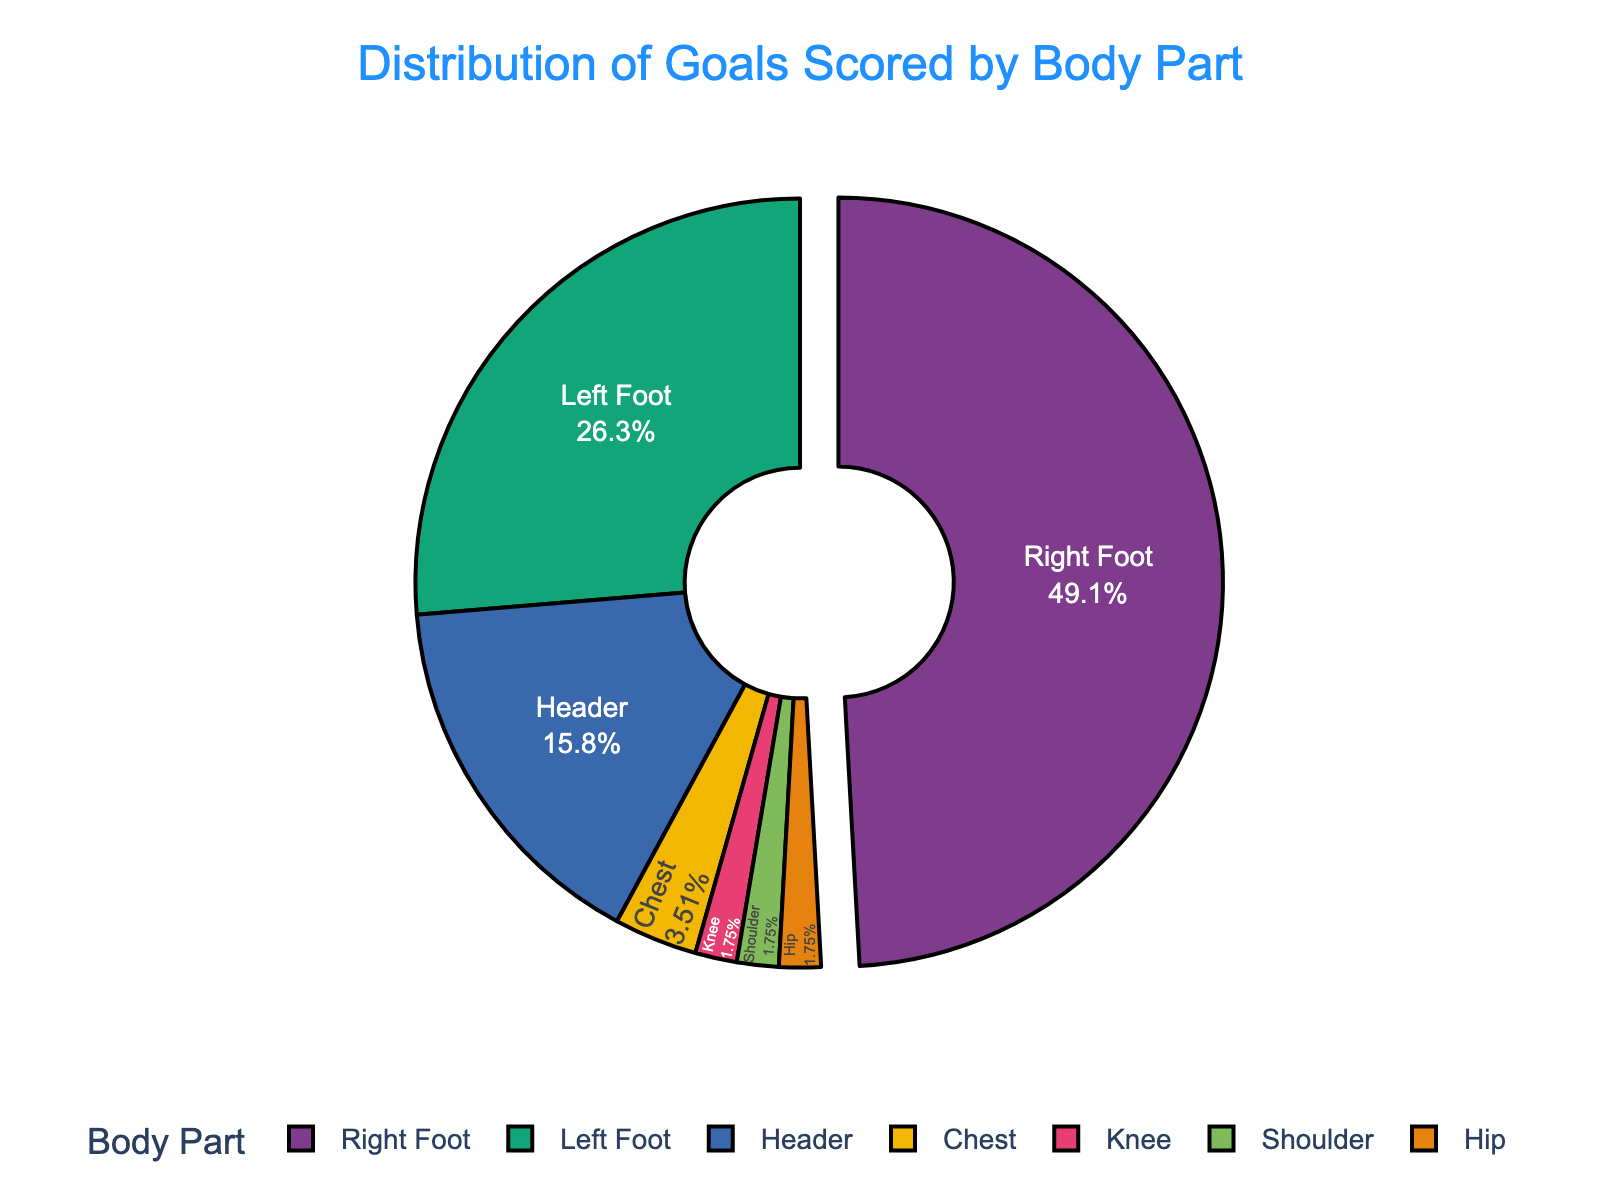What percentage of goals were scored with the right foot? The figure shows that 28 goals were scored with the right foot. To find the percentage, divide the number of right foot goals by the total number of goals and multiply by 100: (28 / (28 + 15 + 9 + 2 + 1 + 1 + 1)) * 100 = (28 / 57) * 100 = 49.12%.
Answer: 49.12% How many more goals were scored with the right foot than with the left foot? The figure shows 28 goals scored with the right foot and 15 with the left foot. Subtract the left foot goals from the right foot goals: 28 - 15 = 13.
Answer: 13 What is the combined percentage of goals scored with Headers, Chest, and Knee? The figure shows 9 goals with headers, 2 with the chest, and 1 with the knee. Combine these values: 9 + 2 + 1 = 12 goals. To find the percentage: (12 / 57) * 100 = 21.05%.
Answer: 21.05% Which body part accounts for the highest percentage of goals? The figure shows different percentages for each body part. The right foot has the highest percentage with 49.12% of the total goals.
Answer: Right Foot Are there any body parts that account for the same percentage of goals? The figure shows that the chest, knee, shoulder, and hip each account for a small portion of goals. Both knee, shoulder, and hip each contributed 1 goal which is (1 / 57) * 100 = 1.75%, indicating an equal percentage.
Answer: Yes, three parts Which contributes more to the total goals, headers or the combined count of goals by chest, knee, shoulder, and hip? Headers contributed 9 goals. Sum the goals from the chest, knee, shoulder, and hip: 2 + 1 + 1 + 1 = 5 goals. Compare the totals: 9 (headers) > 5 (combined).
Answer: Headers If goals scored by the right foot increased by 10, what would the new percentage be? If 10 more goals were added to the right foot: 28 + 10 = 38 right foot goals. The new total goals would be 67. Calculate the new percentage: (38 / 67) * 100 ≈ 56.72%.
Answer: 56.72% Which body part accounted for the lowest number of goals, and what is that number? The figure shows that knee, shoulder, and hip each accounted for 1 goal, which is the lowest.
Answer: Knee, Shoulder, and Hip each with 1 goal 